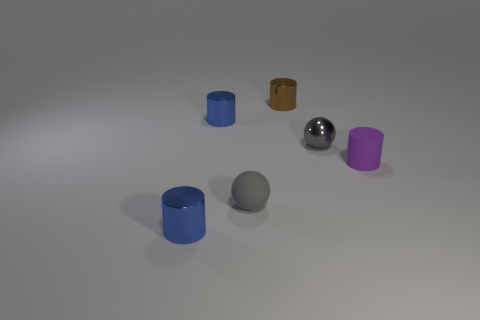Subtract all shiny cylinders. How many cylinders are left? 1 Subtract all spheres. How many objects are left? 4 Subtract all purple cylinders. How many cylinders are left? 3 Add 1 gray spheres. How many objects exist? 7 Subtract 0 purple blocks. How many objects are left? 6 Subtract 3 cylinders. How many cylinders are left? 1 Subtract all gray cylinders. Subtract all purple balls. How many cylinders are left? 4 Subtract all cyan spheres. How many purple cylinders are left? 1 Subtract all small gray metal balls. Subtract all small brown cylinders. How many objects are left? 4 Add 5 gray spheres. How many gray spheres are left? 7 